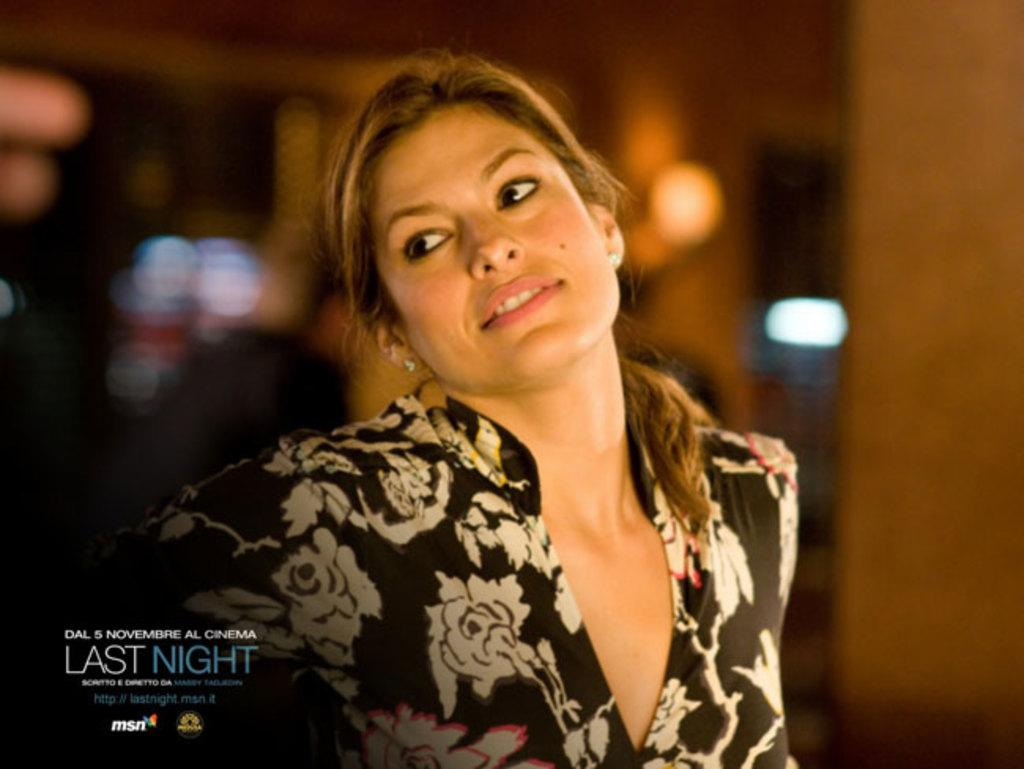What can be observed about the background of the image? The background portion of the picture is blurry. What can be seen in the image besides the background? There are lights visible in the image. Can you describe the person in the image? There is a woman in the image. Where is the additional information located in the image? There is information in the bottom left corner of the image. What type of pan is the woman using to skate on the stove in the image? There is no pan, skating, or stove present in the image. 